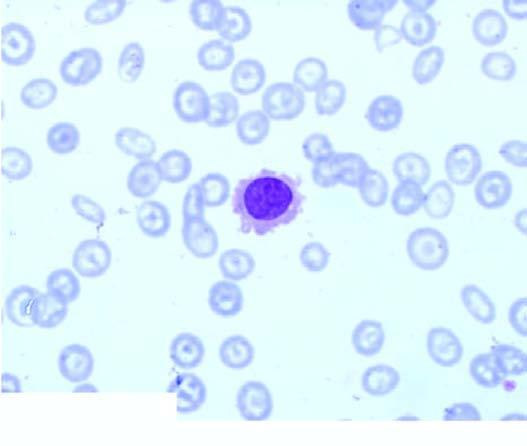what shows replacement of marrow spaces with abnormal mononuclear cells?
Answer the question using a single word or phrase. Trephine biopsy 